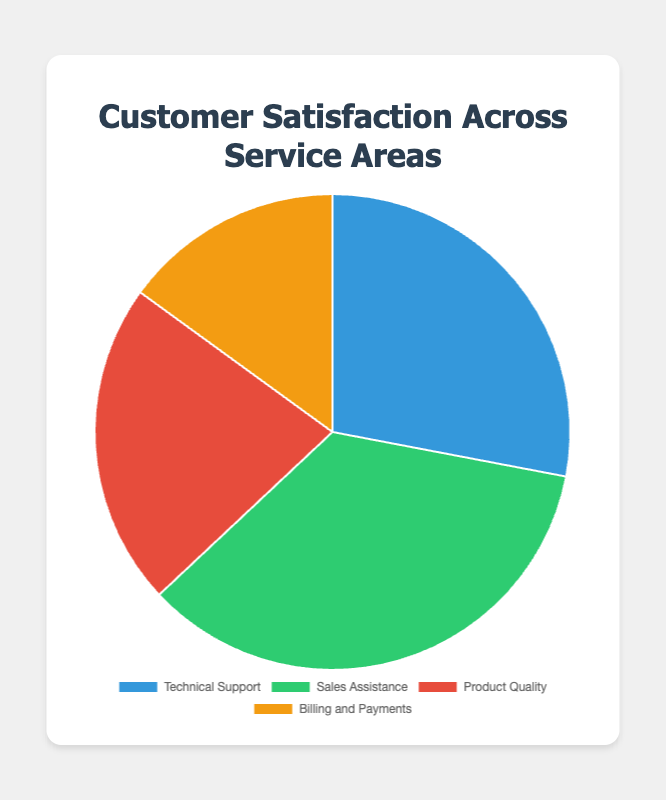Which service area has the highest customer satisfaction? The figure shows the percentages of customer satisfaction across four service areas. The highest customer satisfaction percentage is for Sales Assistance at 35%.
Answer: Sales Assistance Which service area has the lowest customer satisfaction? By looking at the percentages in the pie chart, Billing and Payments has the lowest customer satisfaction at 15%.
Answer: Billing and Payments What is the total customer satisfaction percentage for Technical Support and Product Quality combined? Add the percentages for Technical Support (28%) and Product Quality (22%). 28% + 22% = 50%
Answer: 50% How much higher is the customer satisfaction for Sales Assistance compared to Billing and Payments? Subtract the percentage of Billing and Payments (15%) from Sales Assistance (35%). 35% - 15% = 20%
Answer: 20% Which color represents the Product Quality segment in the pie chart? In the pie chart, Product Quality is represented by the red segment.
Answer: Red Rank the service areas from highest to lowest customer satisfaction percentage. Refer to the percentages: Sales Assistance (35%), Technical Support (28%), Product Quality (22%), Billing and Payments (15%).
Answer: Sales Assistance, Technical Support, Product Quality, Billing and Payments What percentage of customer satisfaction falls under areas other than Sales Assistance? Calculate the sum of percentages for Technical Support, Product Quality, and Billing and Payments. 28% + 22% + 15% = 65%
Answer: 65% What is the difference in customer satisfaction between Technical Support and Product Quality? Subtract the satisfaction percentage of Product Quality (22%) from Technical Support (28%). 28% - 22% = 6%
Answer: 6% What fraction of the pie chart is represented by Sales Assistance in comparison to the total pie? Sales Assistance is 35% of the total 100%, which reduces to the fraction 35/100 or 7/20.
Answer: 7/20 